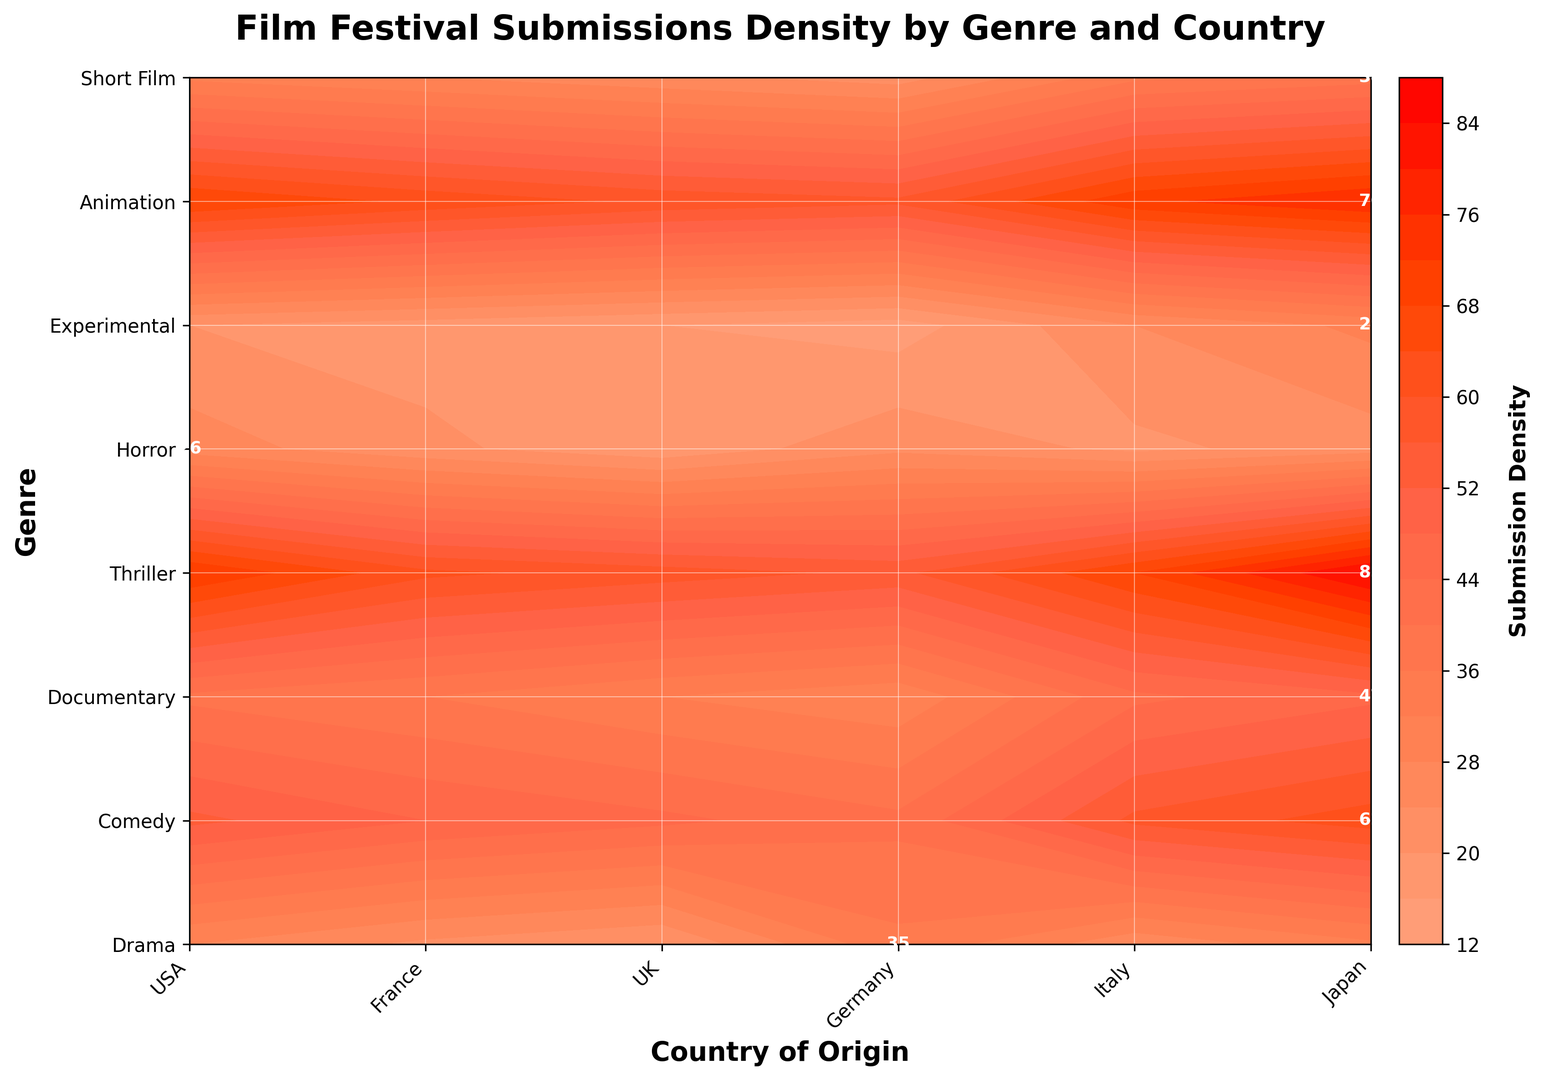Which country has the highest density of Drama film submissions? Look at the Drama genre and identify the highest value. USA has the highest density of 85.
Answer: USA Compare the density of Short Film submissions in the UK and Japan. Which country has a higher density? Locate the density values for Short Film in the UK and Japan. The UK has 71 and Japan has 57, so the UK is higher.
Answer: UK What is the average submission density for the Horror genre across all countries? Sum the densities for Horror across all countries (29 + 20 + 24 + 18 + 16 + 14 = 121) and divide by the number of countries (6). 121 / 6 = 20.17
Answer: 20.17 Which genre has the most consistent density across all countries? Compare the density variation within each genre. Experimental has the most consistent densities (22, 26, 19, 21, 17, 23) with less variation.
Answer: Experimental For the Documentary genre, what is the difference in density between the USA and Italy? Locate the density values for Documentary in the USA and Italy. USA has 47 and Italy has 32. Calculate the difference: 47 - 32 = 15.
Answer: 15 Which genre has the highest submission density in Japan? Locate the density values for all genres in Japan. Animation has the highest density of 35.
Answer: Animation In which country does the Comedy genre have the lowest density? Locate the density values for Comedy in different countries. Japan has the lowest density of 41.
Answer: Japan How does the submission density of Animation compare between USA and Germany? Look at the densities for Animation in the USA (31) and Germany (23). The USA has a higher density.
Answer: USA What is the total submission density for Italy across all genres? Sum the densities for Italy across all genres (58 + 45 + 32 + 25 + 16 + 17 + 20 + 59). The total is 272.
Answer: 272 Identify the genre and country pair with the highest submission density. Look across all genre and country pairs. Drama in the USA has the highest density of 85.
Answer: Drama, USA 